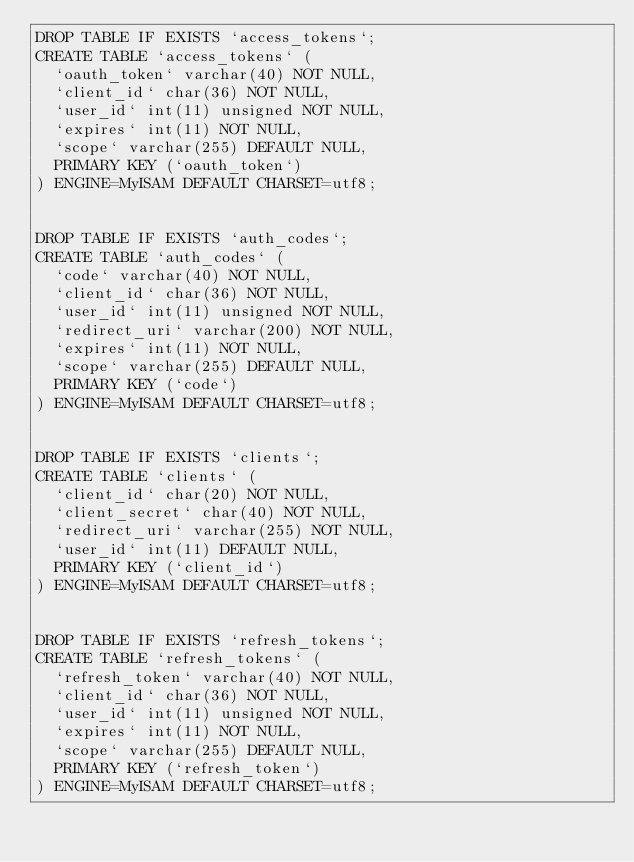Convert code to text. <code><loc_0><loc_0><loc_500><loc_500><_SQL_>DROP TABLE IF EXISTS `access_tokens`;
CREATE TABLE `access_tokens` (
  `oauth_token` varchar(40) NOT NULL,
  `client_id` char(36) NOT NULL,
  `user_id` int(11) unsigned NOT NULL,
  `expires` int(11) NOT NULL,
  `scope` varchar(255) DEFAULT NULL,
  PRIMARY KEY (`oauth_token`)
) ENGINE=MyISAM DEFAULT CHARSET=utf8;


DROP TABLE IF EXISTS `auth_codes`;
CREATE TABLE `auth_codes` (
  `code` varchar(40) NOT NULL,
  `client_id` char(36) NOT NULL,
  `user_id` int(11) unsigned NOT NULL,
  `redirect_uri` varchar(200) NOT NULL,
  `expires` int(11) NOT NULL,
  `scope` varchar(255) DEFAULT NULL,
  PRIMARY KEY (`code`)
) ENGINE=MyISAM DEFAULT CHARSET=utf8;


DROP TABLE IF EXISTS `clients`;
CREATE TABLE `clients` (
  `client_id` char(20) NOT NULL,
  `client_secret` char(40) NOT NULL,
  `redirect_uri` varchar(255) NOT NULL,
  `user_id` int(11) DEFAULT NULL,
  PRIMARY KEY (`client_id`)
) ENGINE=MyISAM DEFAULT CHARSET=utf8;


DROP TABLE IF EXISTS `refresh_tokens`;
CREATE TABLE `refresh_tokens` (
  `refresh_token` varchar(40) NOT NULL,
  `client_id` char(36) NOT NULL,
  `user_id` int(11) unsigned NOT NULL,
  `expires` int(11) NOT NULL,
  `scope` varchar(255) DEFAULT NULL,
  PRIMARY KEY (`refresh_token`)
) ENGINE=MyISAM DEFAULT CHARSET=utf8;</code> 